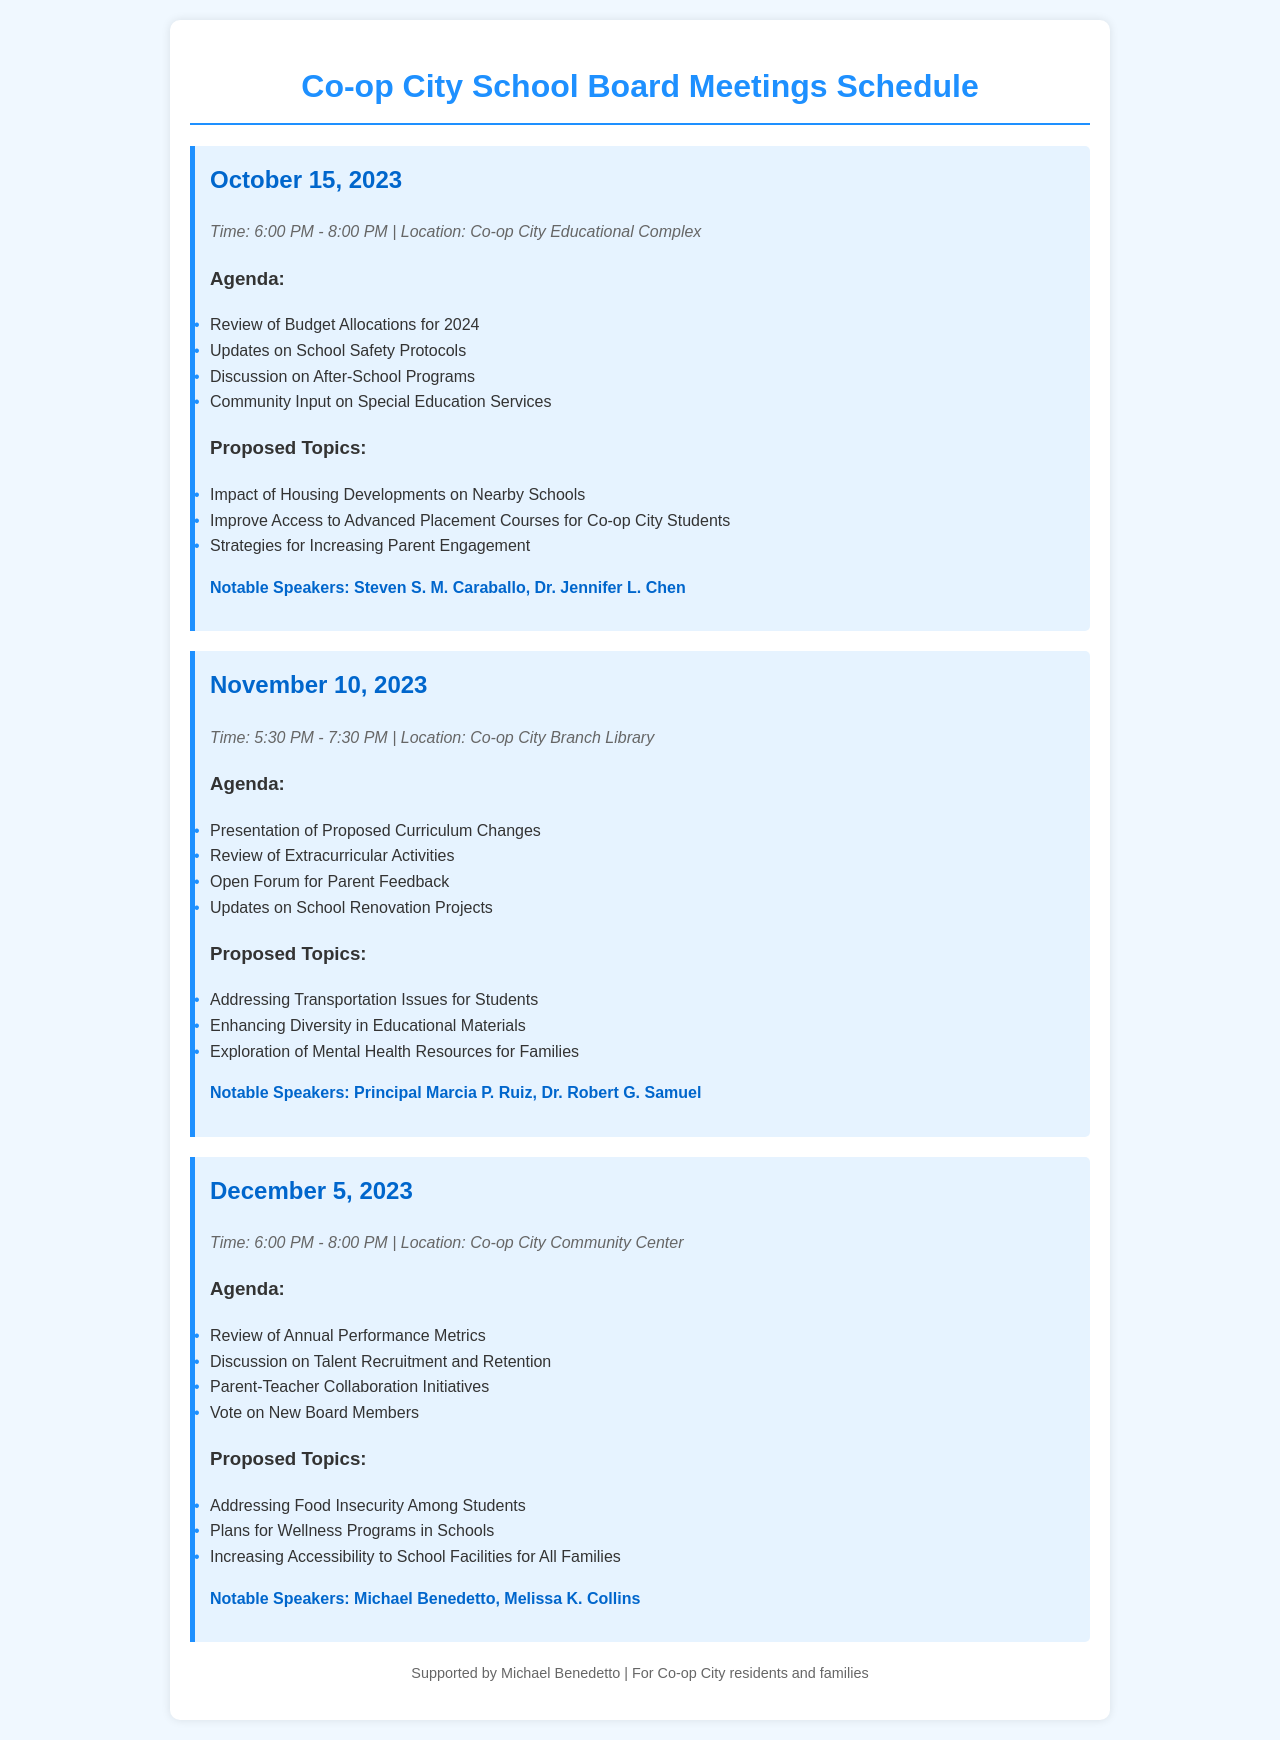What is the date of the next school board meeting? The next school board meeting is listed on the schedule, which states it is on November 10, 2023.
Answer: November 10, 2023 How long is the October 15 meeting scheduled for? The meeting on October 15, 2023, is scheduled from 6:00 PM to 8:00 PM, which is a duration of 2 hours.
Answer: 2 hours Who are the notable speakers for the December meeting? The schedule mentions notable speakers for the December 5 meeting, identifying them as Michael Benedetto and Melissa K. Collins.
Answer: Michael Benedetto, Melissa K. Collins What is one proposed topic for the November meeting? The November 10 meeting has several proposed topics, including "Addressing Transportation Issues for Students."
Answer: Addressing Transportation Issues for Students What is the location of the October meeting? The location of the October 15 meeting is specified as the Co-op City Educational Complex.
Answer: Co-op City Educational Complex How many agenda items are listed for the November meeting? The November 10 meeting agenda lists four items for discussion, mentioning topics including "Presentation of Proposed Curriculum Changes."
Answer: 4 What proposed topic addresses health resources? One proposed topic for the November meeting relates to health, specifically "Exploration of Mental Health Resources for Families."
Answer: Exploration of Mental Health Resources for Families What agenda item concerns after-school programs? The October meeting's agenda includes a specific item titled "Discussion on After-School Programs."
Answer: Discussion on After-School Programs What is the purpose of the meeting on December 5, 2023? The purpose of the December 5 meeting involves reviewing annual performance metrics and related initiatives.
Answer: Review of Annual Performance Metrics 